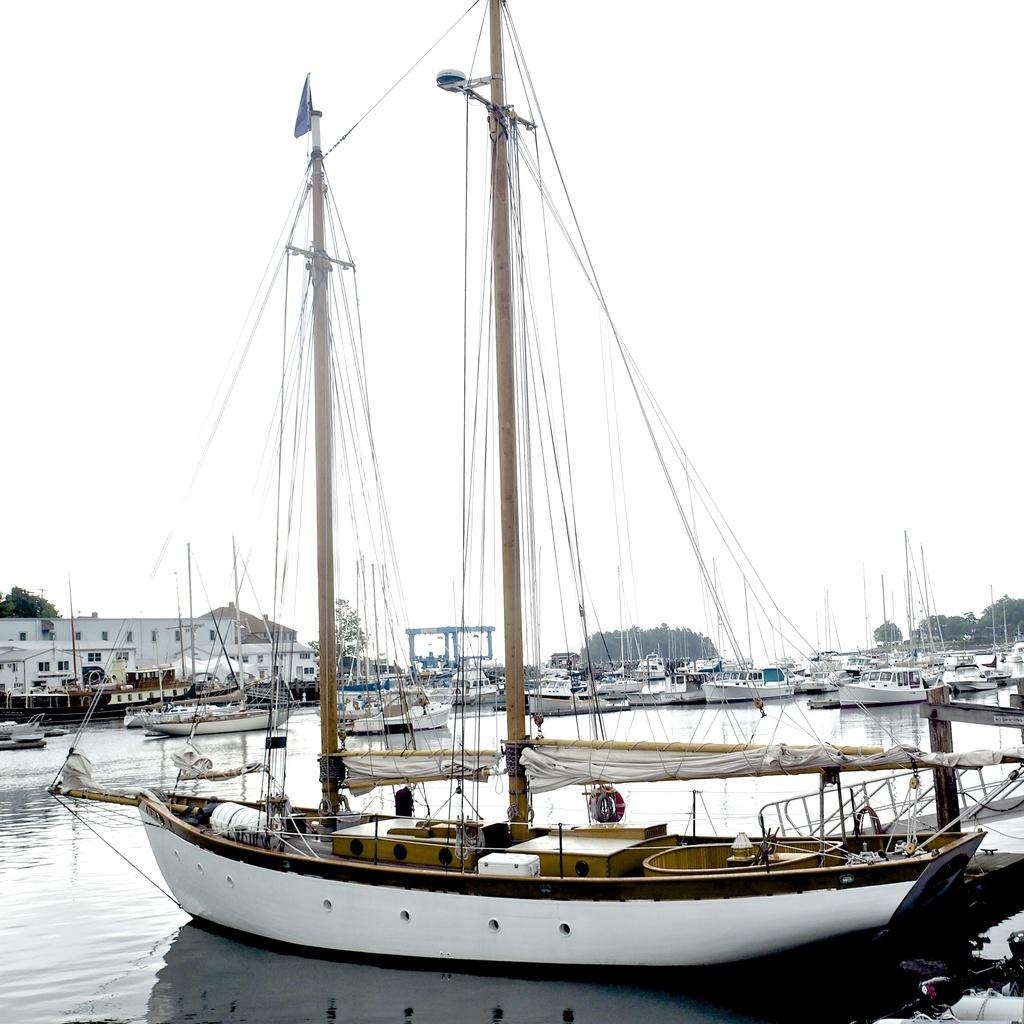What can be seen on the water in the image? There are boats visible on the lake in the image. What type of vegetation is in the middle of the image? There are trees in the middle of the image. What type of structure is present in the image? There is a building in the image. What is visible at the top of the image? The sky is visible at the top of the image. What is the opinion of the throne on the territory in the image? There is no throne or territory present in the image; it features a lake with boats, trees, a building, and the sky. 